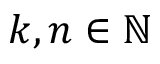Convert formula to latex. <formula><loc_0><loc_0><loc_500><loc_500>k , n \in \mathbb { N }</formula> 